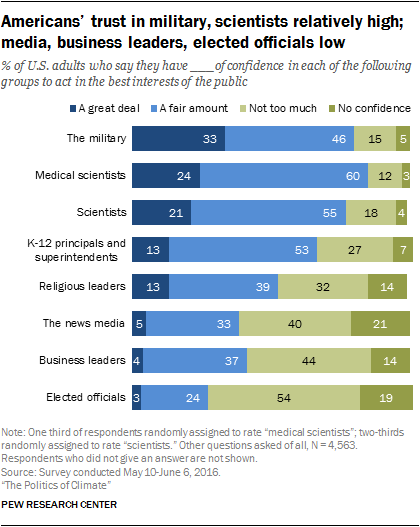List a handful of essential elements in this visual. The average distribution of fair amounts between the news media and business leaders is 35. Four colors are represented in the bar. 